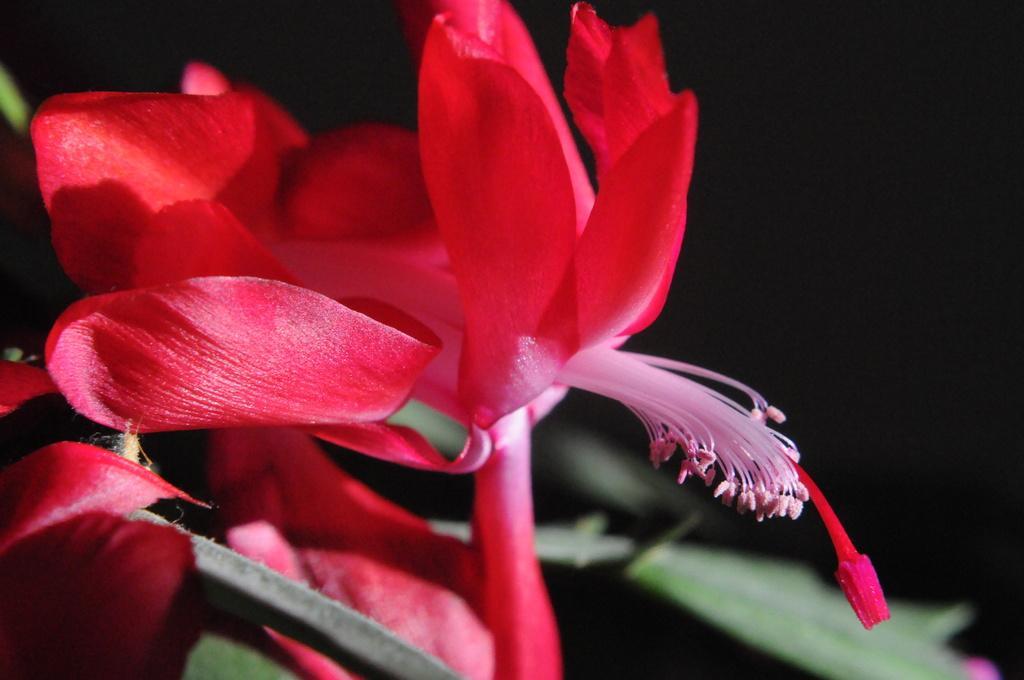Describe this image in one or two sentences. In this image we can see a flower which is in red color. 